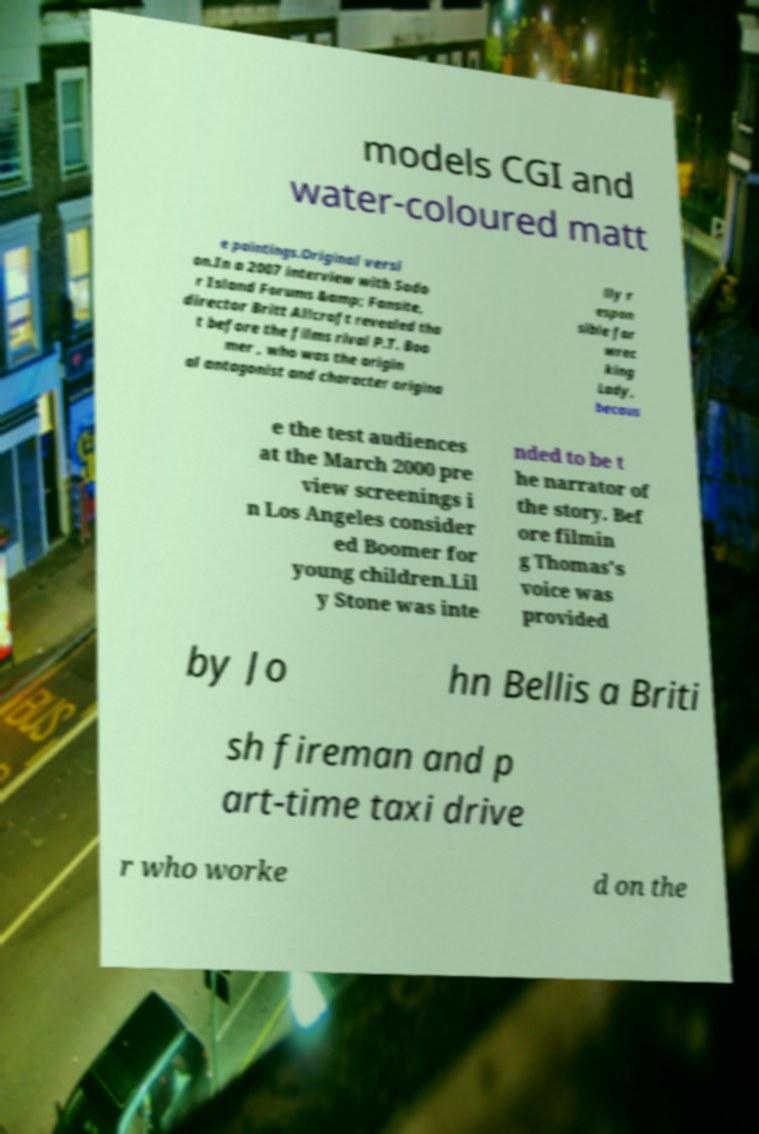I need the written content from this picture converted into text. Can you do that? models CGI and water-coloured matt e paintings.Original versi on.In a 2007 interview with Sodo r Island Forums &amp; Fansite, director Britt Allcroft revealed tha t before the films rival P.T. Boo mer , who was the origin al antagonist and character origina lly r espon sible for wrec king Lady, becaus e the test audiences at the March 2000 pre view screenings i n Los Angeles consider ed Boomer for young children.Lil y Stone was inte nded to be t he narrator of the story. Bef ore filmin g Thomas's voice was provided by Jo hn Bellis a Briti sh fireman and p art-time taxi drive r who worke d on the 